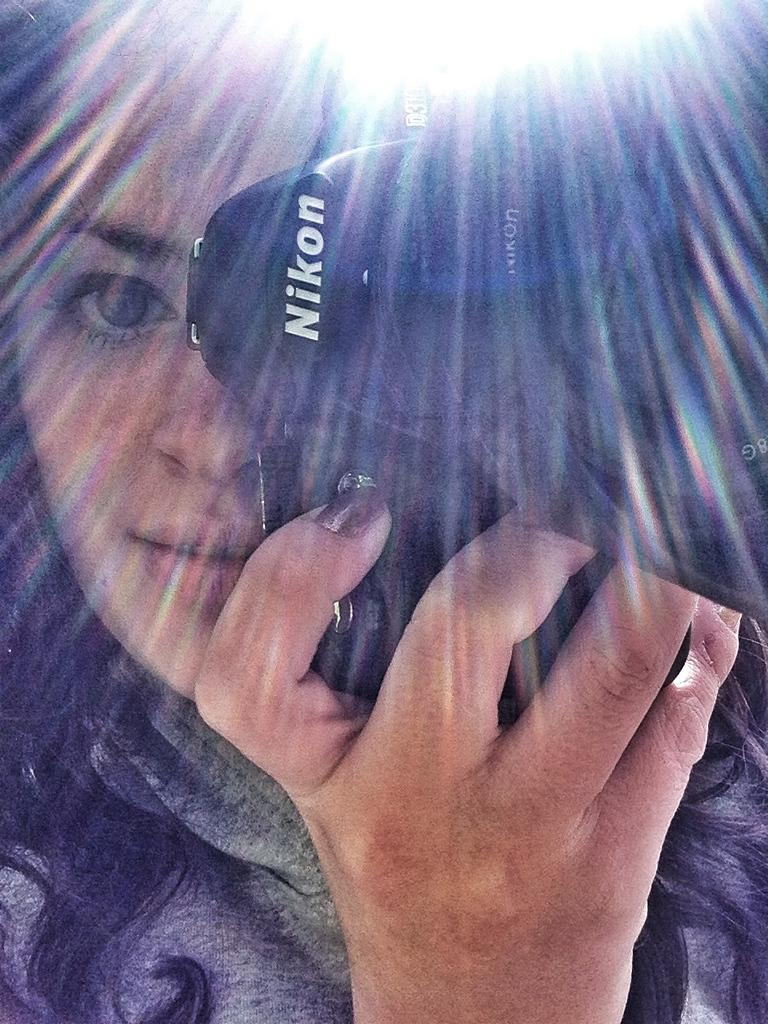Provide a one-sentence caption for the provided image. A girl is holding a camera up to her face. The brand of the camera is Nikon. 